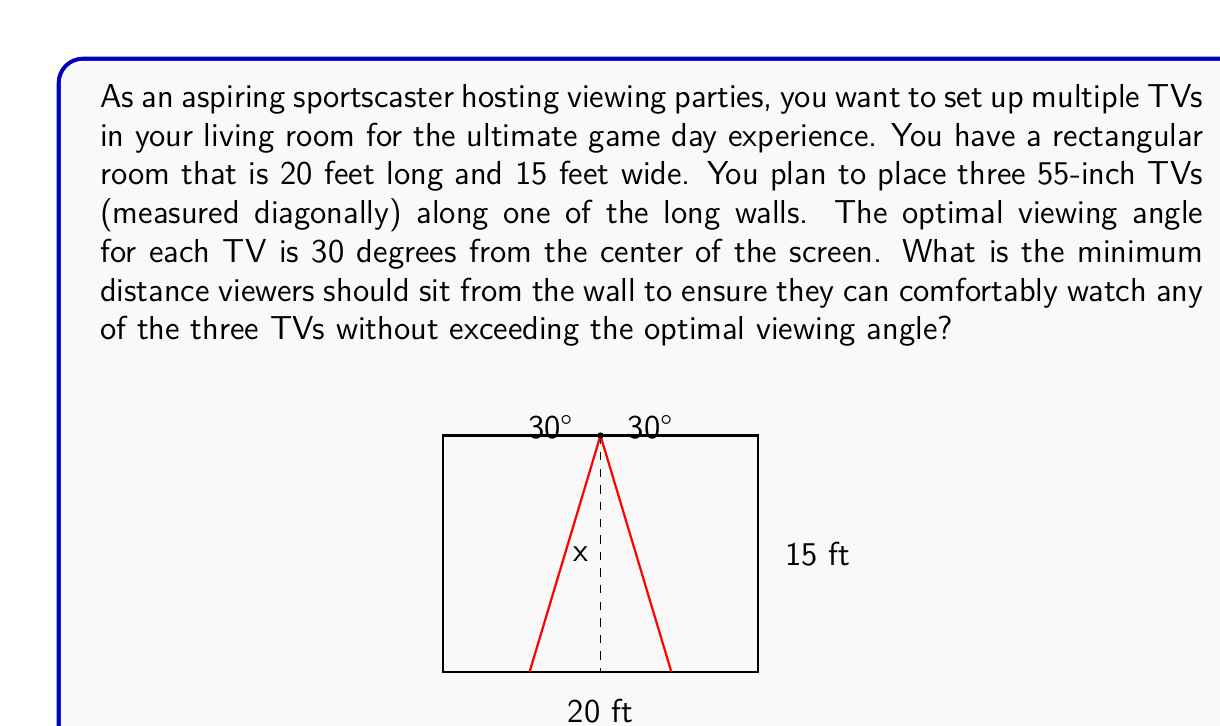Solve this math problem. Let's approach this step-by-step:

1) First, we need to calculate the width of a 55-inch TV. The diagonal measurement is 55 inches, and the aspect ratio of most modern TVs is 16:9. We can use the Pythagorean theorem:

   $$ \text{width}^2 + (\frac{9}{16}\text{width})^2 = 55^2 $$

   Solving this, we get a width of approximately 48 inches or 4 feet.

2) With three 4-foot TVs along a 20-foot wall, we can assume they're evenly spaced. The center TV will be in the middle of the wall, and the other two will be on either side.

3) We're interested in the viewing angle from the edge of the side TVs to the center of the room. This forms a right triangle.

4) The half-width of our viewing area is 10 feet (half the room length).

5) The distance from the center of the room to the edge of a side TV is:
   $$ 10 - 2 = 8 \text{ feet} $$

6) Now we can use the tangent function to find the required distance (x):

   $$ \tan(30°) = \frac{8}{x} $$

7) Solving for x:

   $$ x = \frac{8}{\tan(30°)} $$

8) $\tan(30°) = \frac{1}{\sqrt{3}}$, so:

   $$ x = 8\sqrt{3} \approx 13.86 \text{ feet} $$

Therefore, viewers should sit at least 13.86 feet from the wall to ensure they can comfortably watch any of the three TVs without exceeding the optimal viewing angle.
Answer: The minimum distance viewers should sit from the wall is approximately 13.86 feet or $8\sqrt{3}$ feet. 